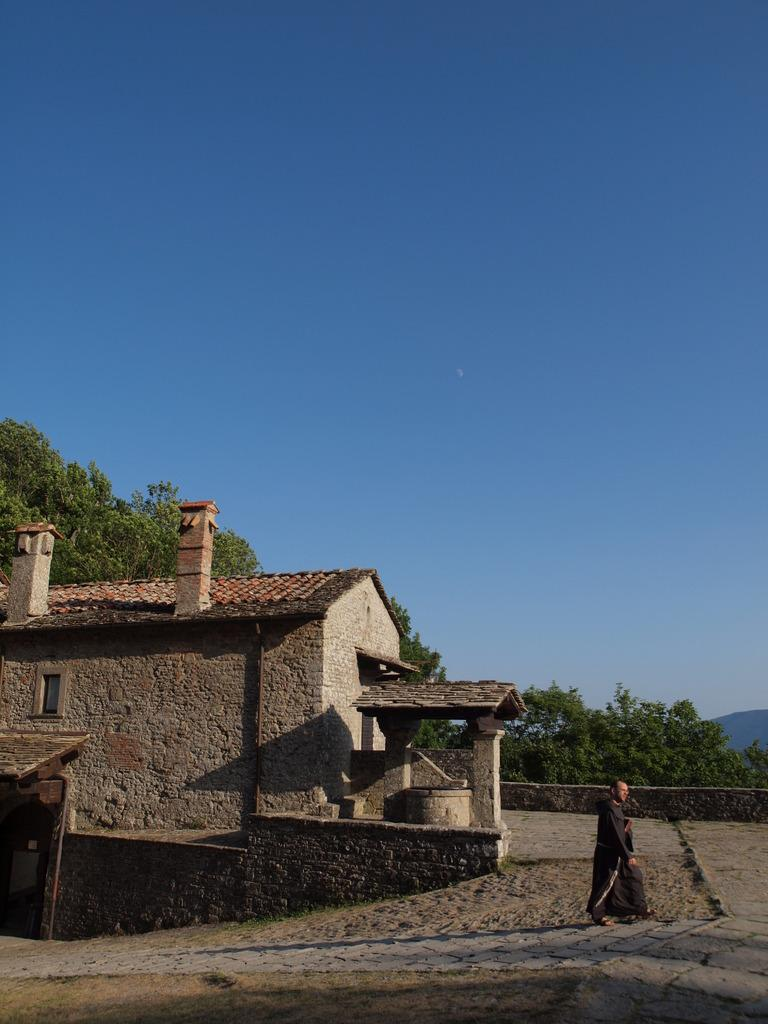What type of structure is visible in the image? There is a house in the image. What is happening in front of the house? There is a person walking on a path in front of the house. What can be seen in the background of the image? There are trees and the sky visible in the background of the image. Can you see the person wearing a crown while walking in the image? There is no crown visible in the image; the person is simply walking on the path. 